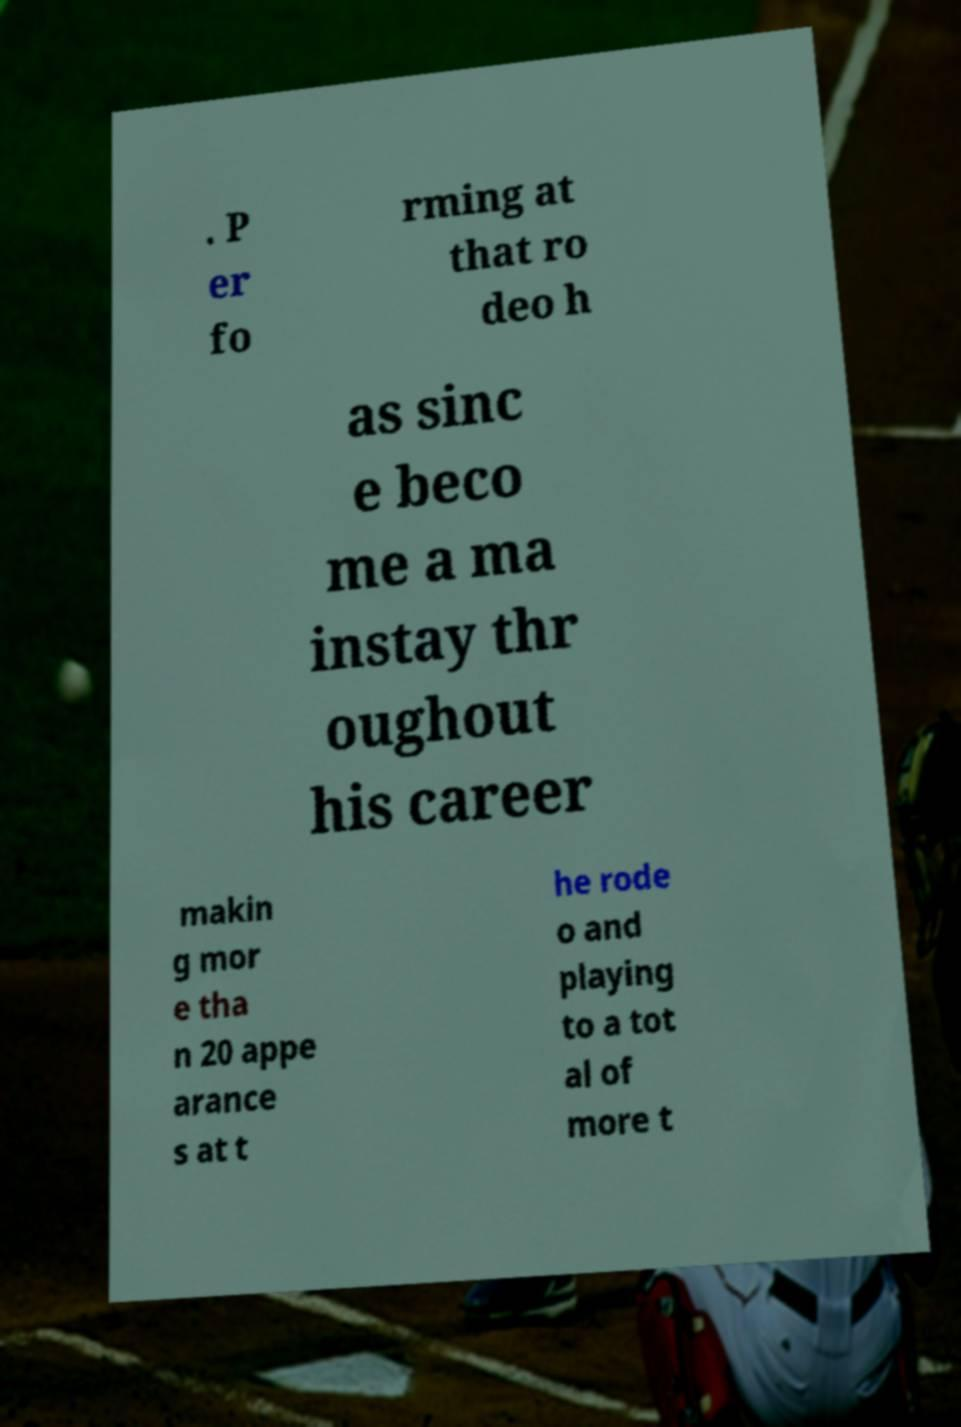Could you assist in decoding the text presented in this image and type it out clearly? . P er fo rming at that ro deo h as sinc e beco me a ma instay thr oughout his career makin g mor e tha n 20 appe arance s at t he rode o and playing to a tot al of more t 